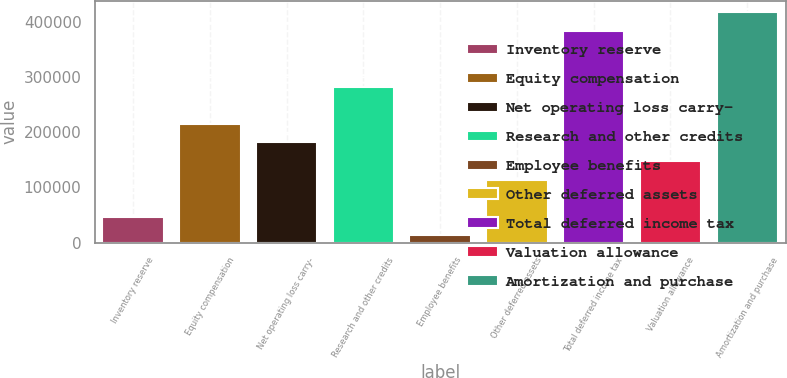<chart> <loc_0><loc_0><loc_500><loc_500><bar_chart><fcel>Inventory reserve<fcel>Equity compensation<fcel>Net operating loss carry-<fcel>Research and other credits<fcel>Employee benefits<fcel>Other deferred assets<fcel>Total deferred income tax<fcel>Valuation allowance<fcel>Amortization and purchase<nl><fcel>46898.2<fcel>215154<fcel>181503<fcel>282457<fcel>13247<fcel>114201<fcel>383410<fcel>147852<fcel>417061<nl></chart> 